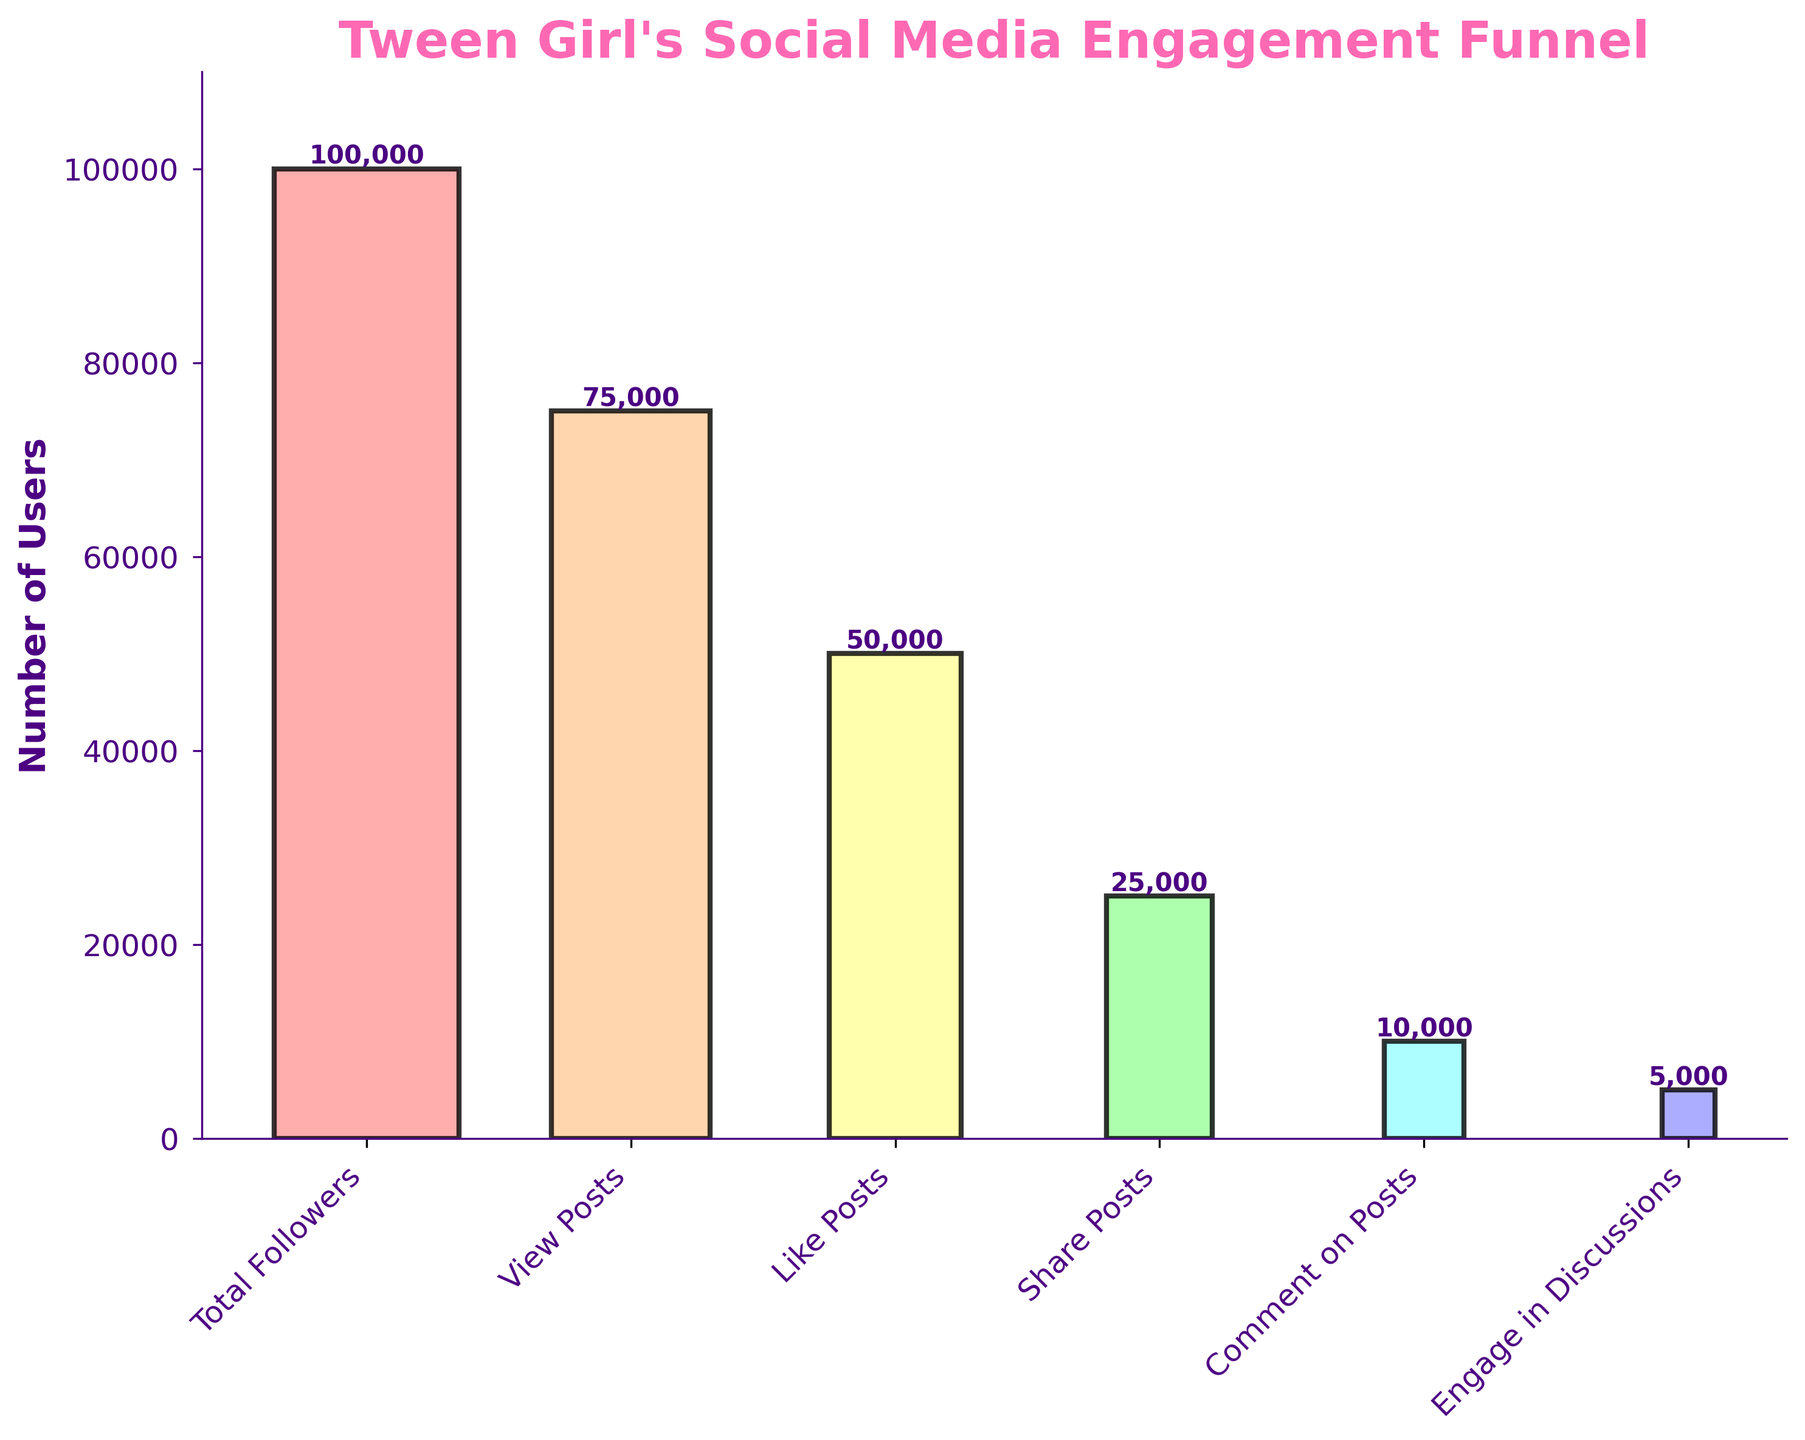What is the title of the funnel chart? The title is located at the top of the figure and is usually in larger, bold text.
Answer: Tween Girl's Social Media Engagement Funnel How many stages are there in the funnel chart? To determine the number of stages, count each labeled bar on the x-axis.
Answer: 6 What is the color of the 'Total Followers' stage? The color of each bar can be identified visually. The first bar appears in a specific color.
Answer: Light red How many users view posts? Locate the 'View Posts' stage and check the numerical value associated with it.
Answer: 75,000 What is the difference in the number of users between the 'Like Posts' and 'Share Posts' stages? Subtract the number of users in the 'Share Posts' stage from the number of users in the 'Like Posts' stage (50,000 - 25,000).
Answer: 25,000 Which stage has the smallest number of users? Compare all stages and identify the one with the lowest numerical value.
Answer: Engage in Discussions How many users comment on posts? Find the 'Comment on Posts' stage and see the numerical value associated with it.
Answer: 10,000 What percentage of total followers engage in discussions? Divide the number of users who engage in discussions by the total number of followers, then multiply by 100 to get the percentage (5,000 / 100,000 * 100).
Answer: 5% Is the drop-off between 'View Posts' and 'Like Posts' larger or smaller than between 'Comment on Posts' and 'Engage in Discussions'? Compare the differences: 'View Posts' to 'Like Posts' (75,000 - 50,000), and 'Comment on Posts' to 'Engage in Discussions' (10,000 - 5,000).
Answer: Larger By how much do the users decrease from 'View Posts' to 'Engage in Discussions'? Subtract the number of users in the 'Engage in Discussions' stage from the number in the 'View Posts' stage (75,000 - 5,000).
Answer: 70,000 